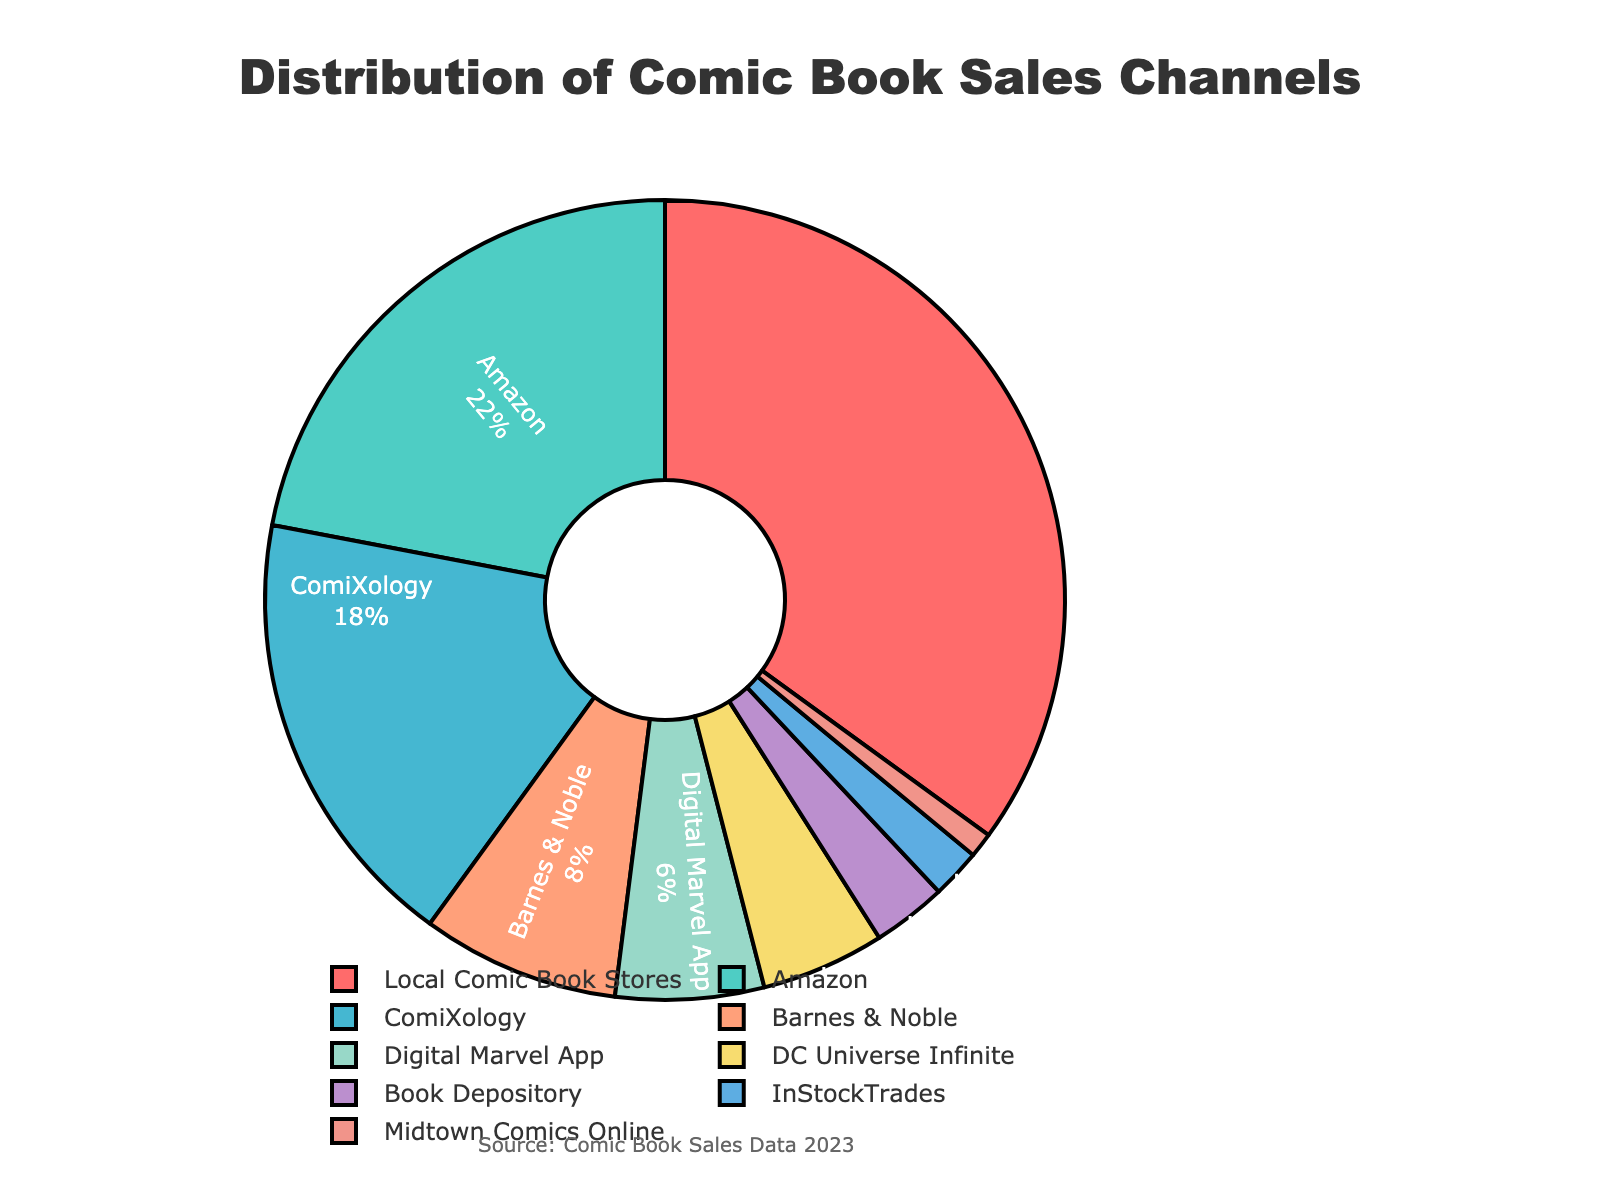Which sales channel has the highest percentage of comic book sales? Looking at the pie chart, we identify "Local Comic Book Stores" occupying the largest segment.
Answer: Local Comic Book Stores How much more percentage of comic book sales does Amazon have compared to ComiXology? Amazon has 22% and ComiXology has 18%. Subtracting the percentage of ComiXology from Amazon: 22% - 18% = 4%.
Answer: 4% What's the combined percentage of comic book sales for Digital Marvel App and DC Universe Infinite? Add the percentages for Digital Marvel App (6%) and DC Universe Infinite (5%): 6% + 5% = 11%.
Answer: 11% If we combine all digital platforms (ComiXology, Digital Marvel App, DC Universe Infinite) into one category, what’s the total percentage? Add the percentages for ComiXology (18%), Digital Marvel App (6%), and DC Universe Infinite (5%): 18% + 6% + 5% = 29%.
Answer: 29% Which sales channel has the smallest percentage of comic book sales, and what is that percentage? Midtown Comics Online has the smallest segment, which corresponds to 1%.
Answer: Midtown Comics Online, 1% Is there a greater difference in percentage between Local Comic Book Stores and Amazon or between Amazon and ComiXology? Calculate both differences: 
1) Local Comic Book Stores and Amazon: 35% - 22% = 13%.
2) Amazon and ComiXology: 22% - 18% = 4%.
Comparing both, the difference between Local Comic Book Stores and Amazon is greater.
Answer: Local Comic Book Stores and Amazon What percentage of sales do the combined channels other than Local Comic Book Stores represent? Subtract the percentage of Local Comic Book Stores from 100%: 100% - 35% = 65%.
Answer: 65% Which visual segment represents sales from Barnes & Noble, and how can it be identified? The segment labeled "Barnes & Noble" with 8% is represented by a corresponding color in the pie chart. To identify, look for this label among the chart segments.
Answer: 8% Among the channels with single-digit percentages, which one has the highest percentage? Compare percentages from the channels with single digits: Barnes & Noble (8%), Digital Marvel App (6%), DC Universe Infinite (5%), Book Depository (3%), InStockTrades (2%), and Midtown Comics Online (1%). The highest among them is Barnes & Noble with 8%.
Answer: Barnes & Noble Which channel ranks third in terms of sales percentage? Looking at the pie chart, the channel with the third highest percentage after Local Comic Book Stores and Amazon is ComiXology with 18%.
Answer: ComiXology 